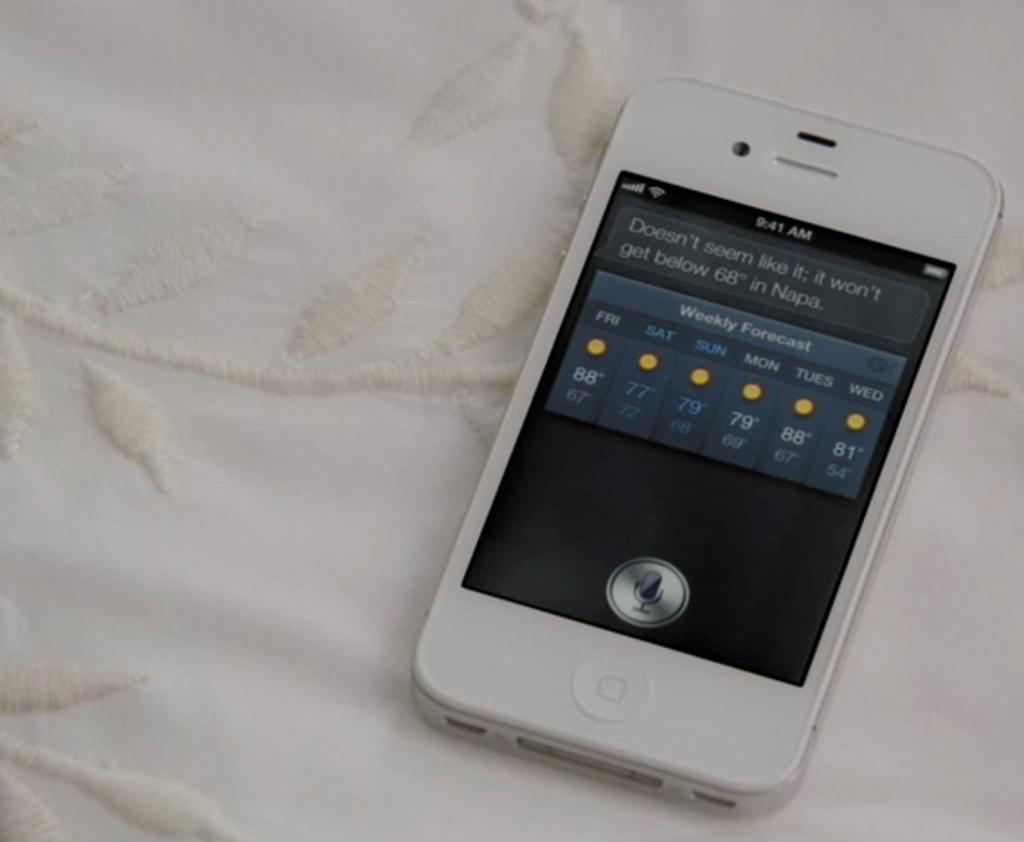What time is shown on the phone?
Make the answer very short. 9:41 am. What day will it be 81 degrees?
Your answer should be very brief. Wed. 